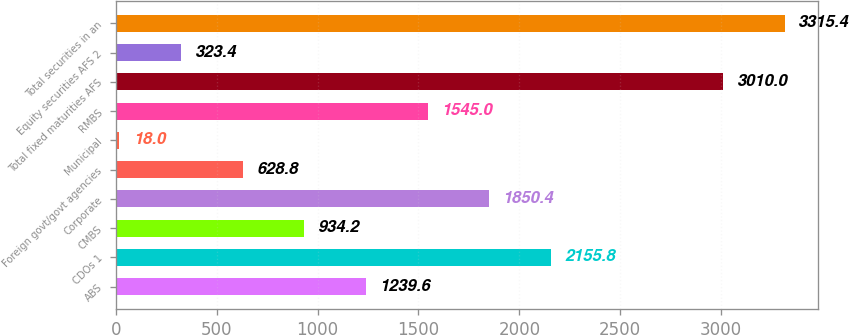Convert chart. <chart><loc_0><loc_0><loc_500><loc_500><bar_chart><fcel>ABS<fcel>CDOs 1<fcel>CMBS<fcel>Corporate<fcel>Foreign govt/govt agencies<fcel>Municipal<fcel>RMBS<fcel>Total fixed maturities AFS<fcel>Equity securities AFS 2<fcel>Total securities in an<nl><fcel>1239.6<fcel>2155.8<fcel>934.2<fcel>1850.4<fcel>628.8<fcel>18<fcel>1545<fcel>3010<fcel>323.4<fcel>3315.4<nl></chart> 